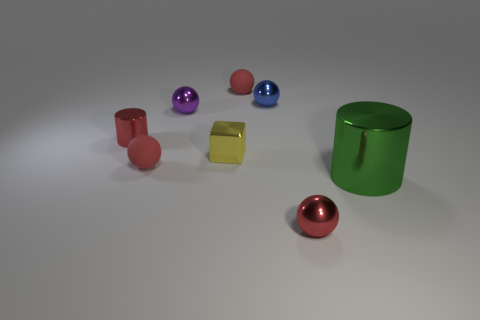How many red spheres must be subtracted to get 1 red spheres? 2 Subtract all yellow cylinders. How many red balls are left? 3 Subtract all blue balls. How many balls are left? 4 Subtract 2 spheres. How many spheres are left? 3 Subtract all blue metal spheres. How many spheres are left? 4 Subtract all yellow balls. Subtract all blue cylinders. How many balls are left? 5 Add 1 yellow shiny balls. How many objects exist? 9 Subtract all balls. How many objects are left? 3 Subtract all tiny red things. Subtract all metallic balls. How many objects are left? 1 Add 4 blue balls. How many blue balls are left? 5 